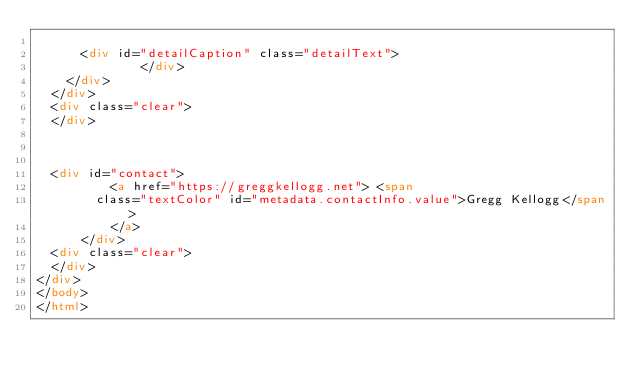<code> <loc_0><loc_0><loc_500><loc_500><_HTML_>	  
      <div id="detailCaption" class="detailText">
              </div>
    </div>
  </div>
  <div class="clear">
  </div>


  
  <div id="contact">
          <a href="https://greggkellogg.net"> <span
        class="textColor" id="metadata.contactInfo.value">Gregg Kellogg</span>
          </a>
      </div>
  <div class="clear">
  </div>
</div>
</body>
</html>


</code> 